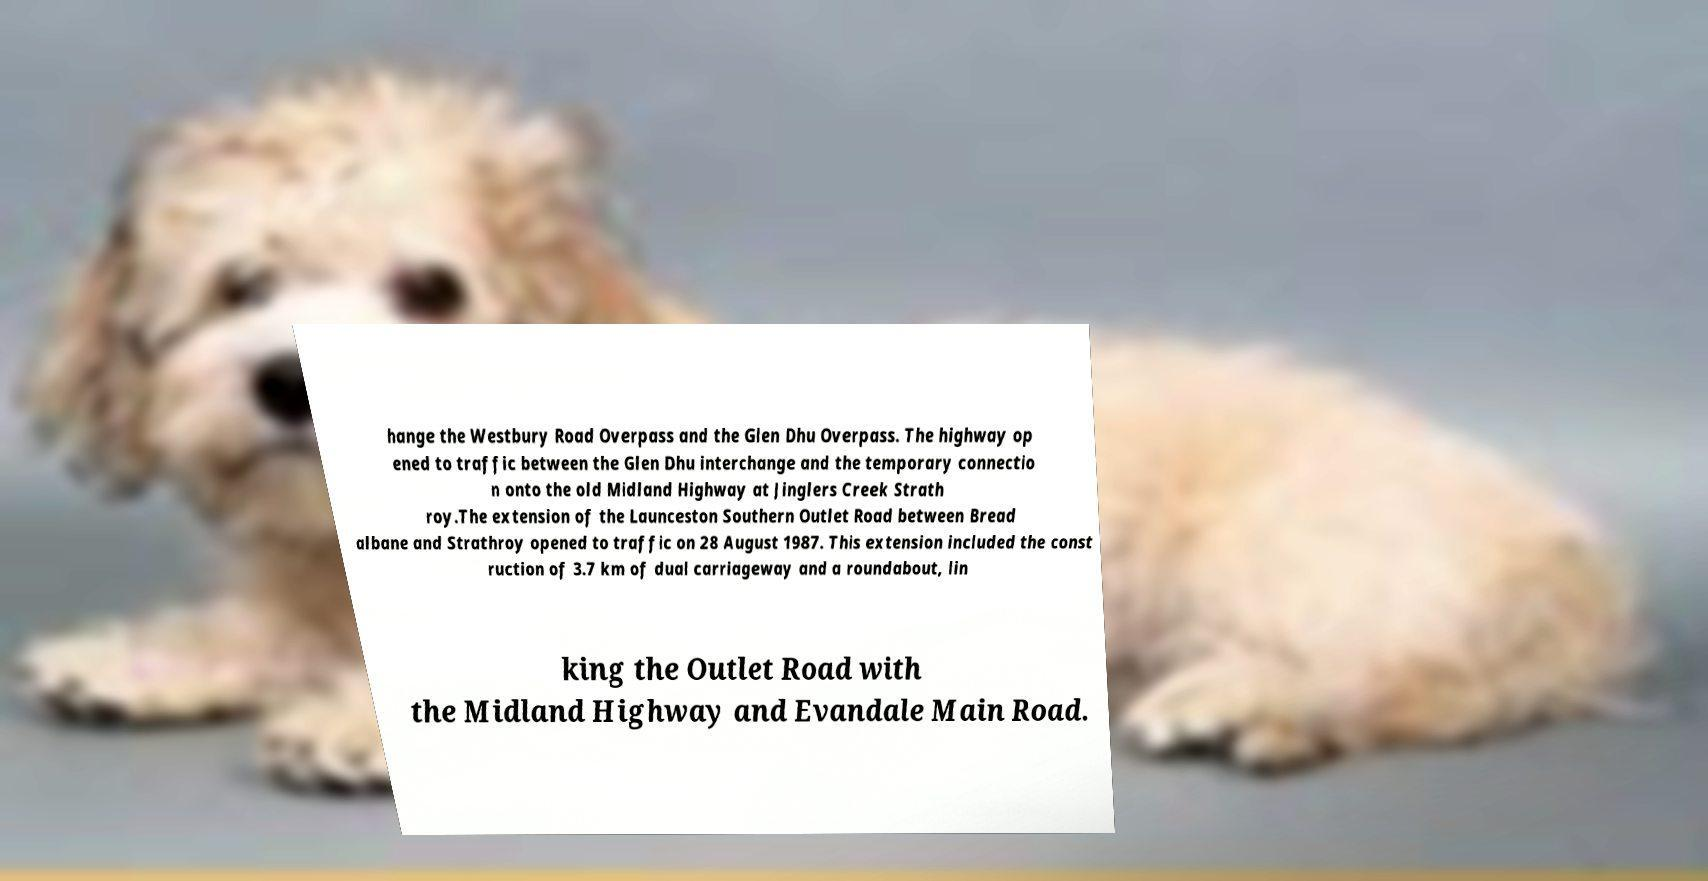Can you accurately transcribe the text from the provided image for me? hange the Westbury Road Overpass and the Glen Dhu Overpass. The highway op ened to traffic between the Glen Dhu interchange and the temporary connectio n onto the old Midland Highway at Jinglers Creek Strath roy.The extension of the Launceston Southern Outlet Road between Bread albane and Strathroy opened to traffic on 28 August 1987. This extension included the const ruction of 3.7 km of dual carriageway and a roundabout, lin king the Outlet Road with the Midland Highway and Evandale Main Road. 